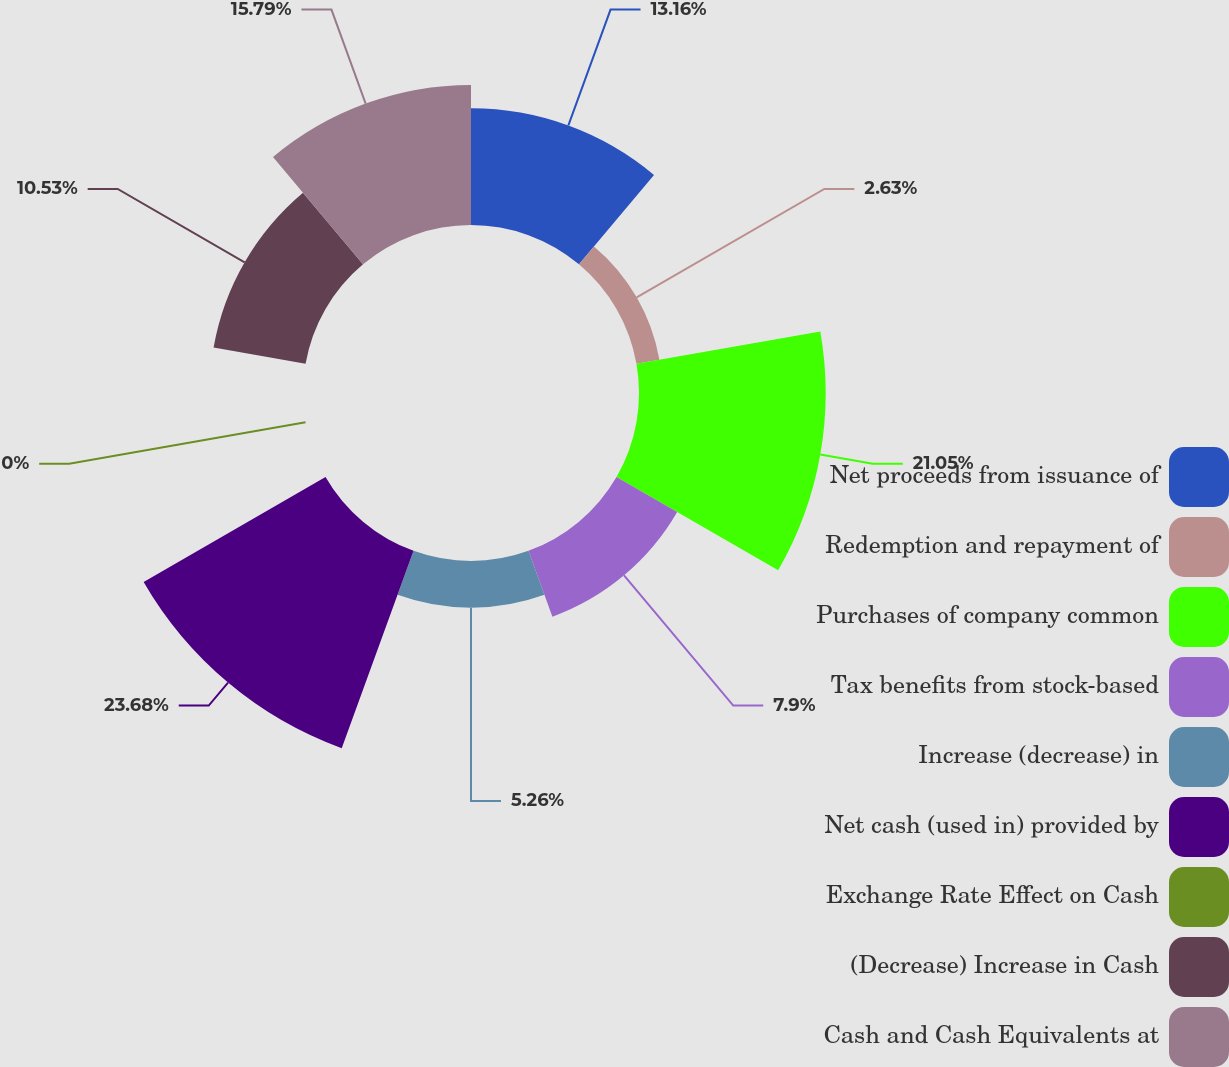<chart> <loc_0><loc_0><loc_500><loc_500><pie_chart><fcel>Net proceeds from issuance of<fcel>Redemption and repayment of<fcel>Purchases of company common<fcel>Tax benefits from stock-based<fcel>Increase (decrease) in<fcel>Net cash (used in) provided by<fcel>Exchange Rate Effect on Cash<fcel>(Decrease) Increase in Cash<fcel>Cash and Cash Equivalents at<nl><fcel>13.16%<fcel>2.63%<fcel>21.05%<fcel>7.9%<fcel>5.26%<fcel>23.68%<fcel>0.0%<fcel>10.53%<fcel>15.79%<nl></chart> 